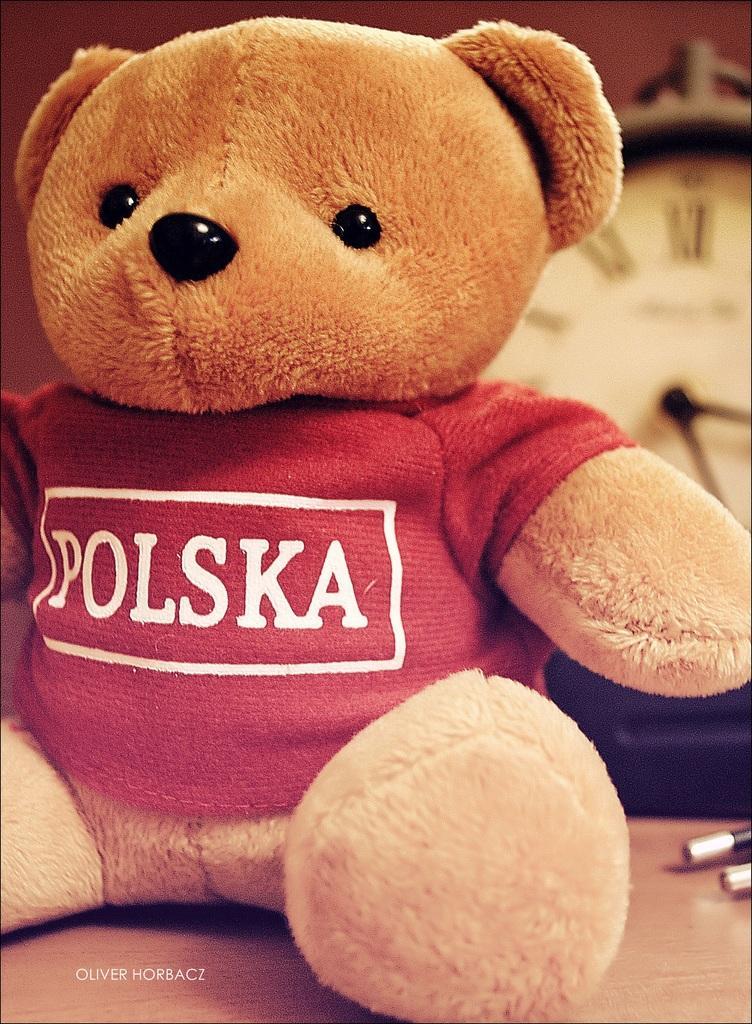How would you summarize this image in a sentence or two? In this picture we can see a teddy bear with red colored dress on the table. And on the back there is a clock. 